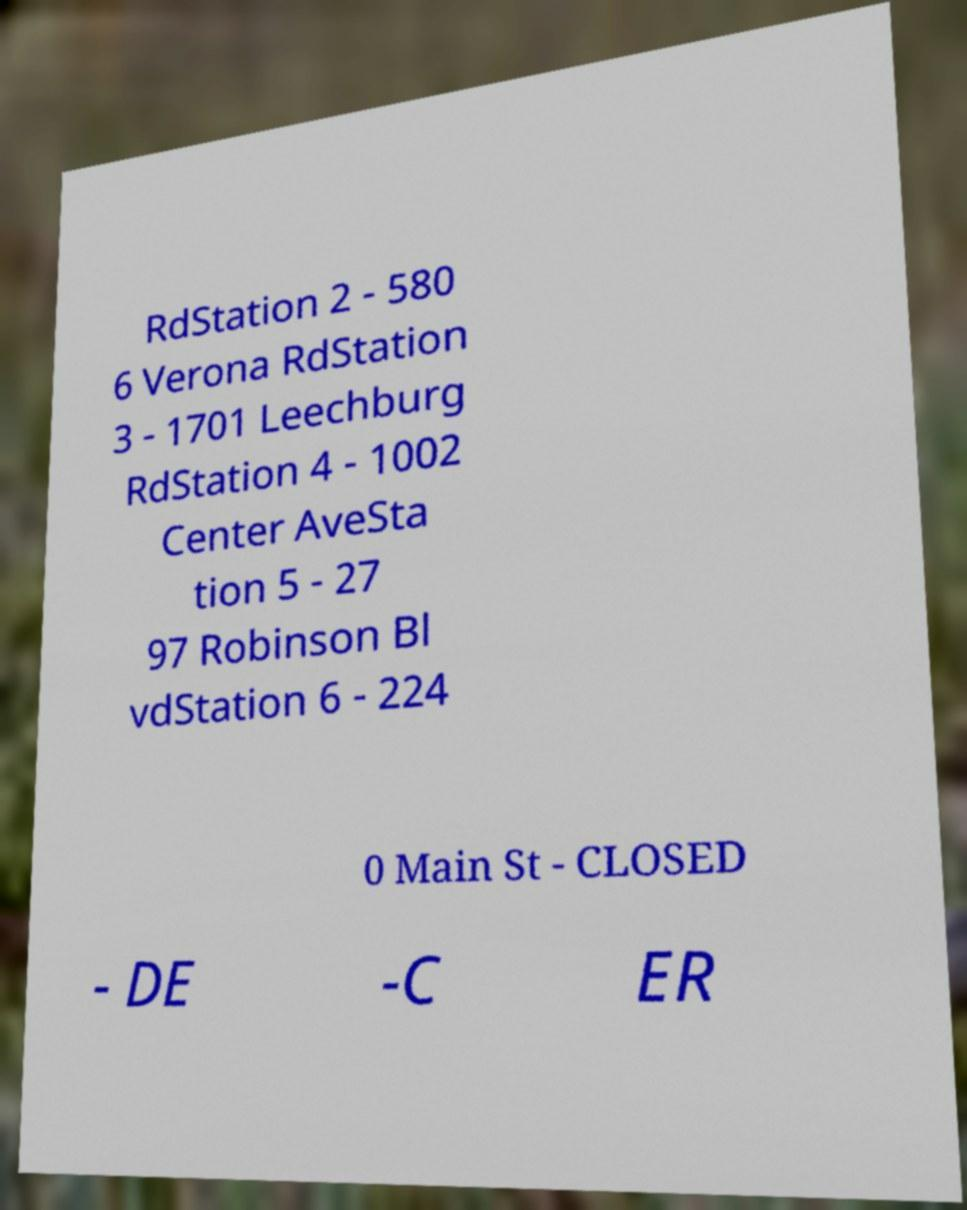Can you accurately transcribe the text from the provided image for me? RdStation 2 - 580 6 Verona RdStation 3 - 1701 Leechburg RdStation 4 - 1002 Center AveSta tion 5 - 27 97 Robinson Bl vdStation 6 - 224 0 Main St - CLOSED - DE -C ER 